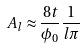Convert formula to latex. <formula><loc_0><loc_0><loc_500><loc_500>A _ { l } \approx \frac { 8 t } { \phi _ { 0 } } \frac { 1 } { l \pi }</formula> 